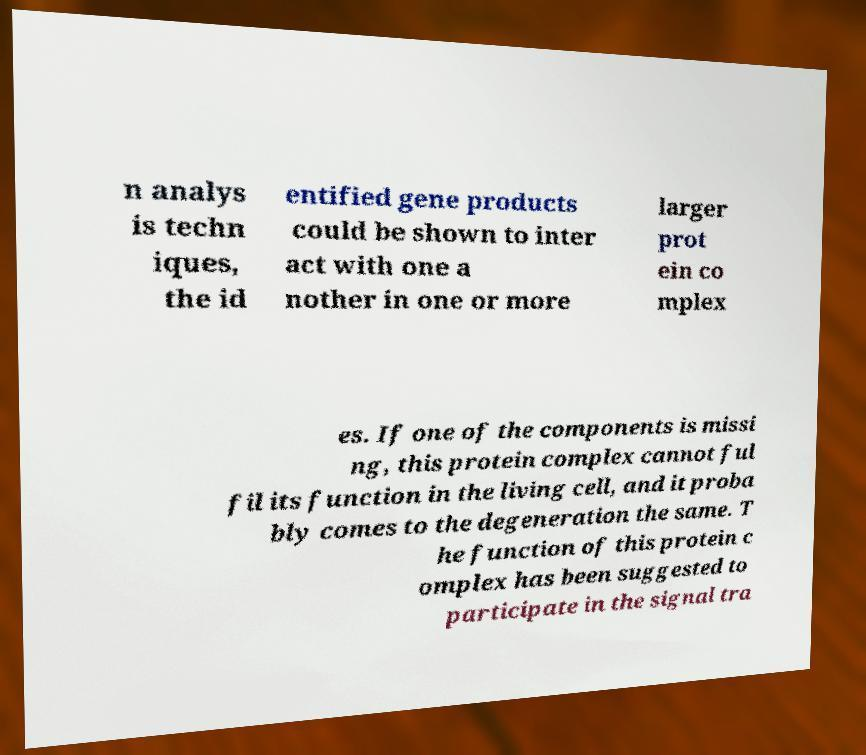What messages or text are displayed in this image? I need them in a readable, typed format. n analys is techn iques, the id entified gene products could be shown to inter act with one a nother in one or more larger prot ein co mplex es. If one of the components is missi ng, this protein complex cannot ful fil its function in the living cell, and it proba bly comes to the degeneration the same. T he function of this protein c omplex has been suggested to participate in the signal tra 